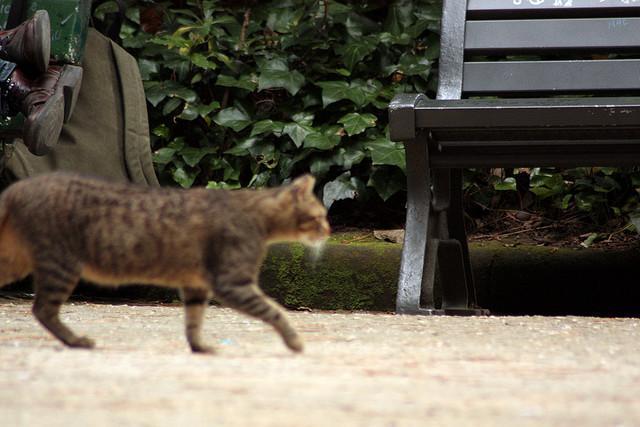How many giraffes are there?
Give a very brief answer. 0. 